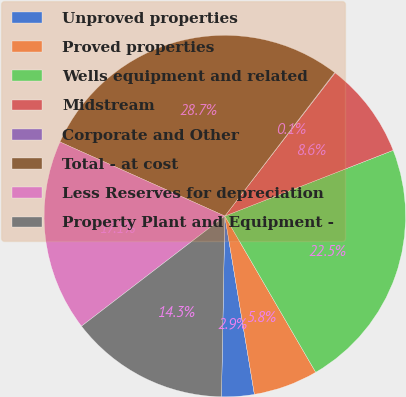Convert chart to OTSL. <chart><loc_0><loc_0><loc_500><loc_500><pie_chart><fcel>Unproved properties<fcel>Proved properties<fcel>Wells equipment and related<fcel>Midstream<fcel>Corporate and Other<fcel>Total - at cost<fcel>Less Reserves for depreciation<fcel>Property Plant and Equipment -<nl><fcel>2.91%<fcel>5.77%<fcel>22.54%<fcel>8.63%<fcel>0.05%<fcel>28.67%<fcel>17.15%<fcel>14.28%<nl></chart> 